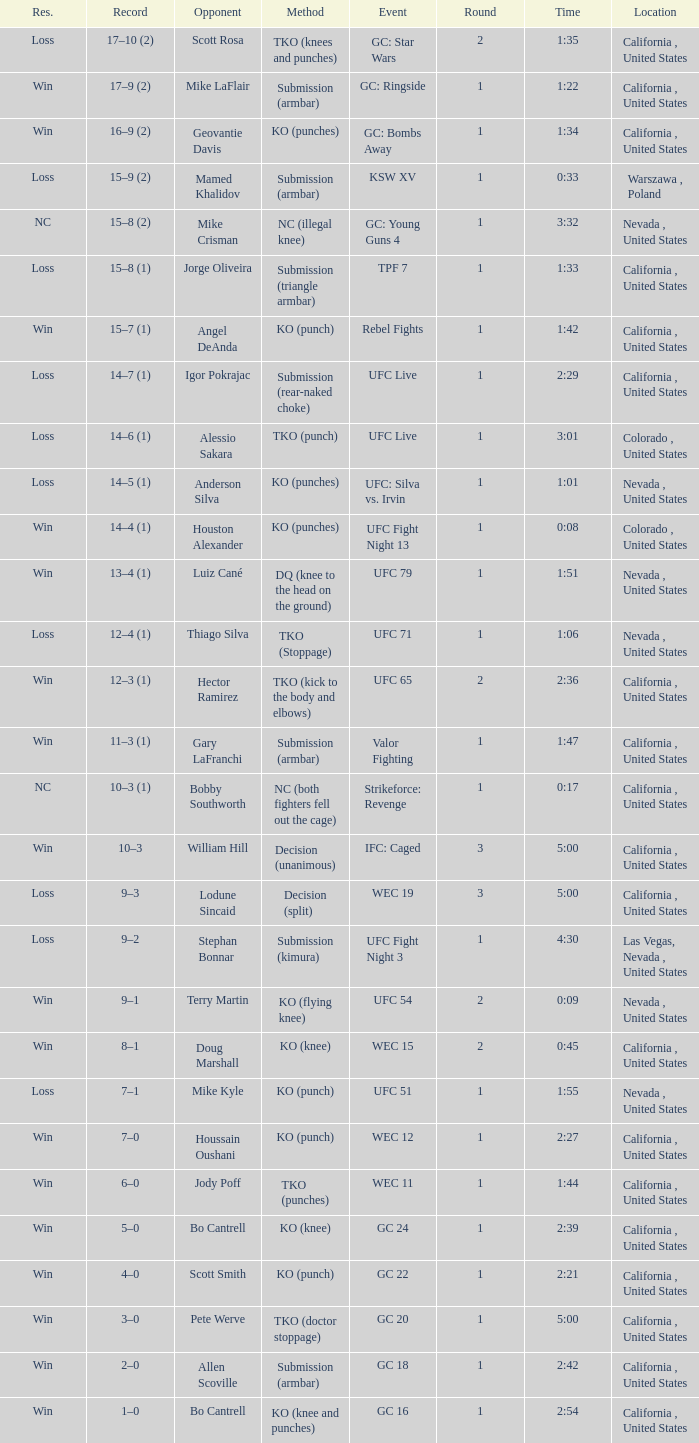What is the method where there is a loss with time 5:00? Decision (split). 